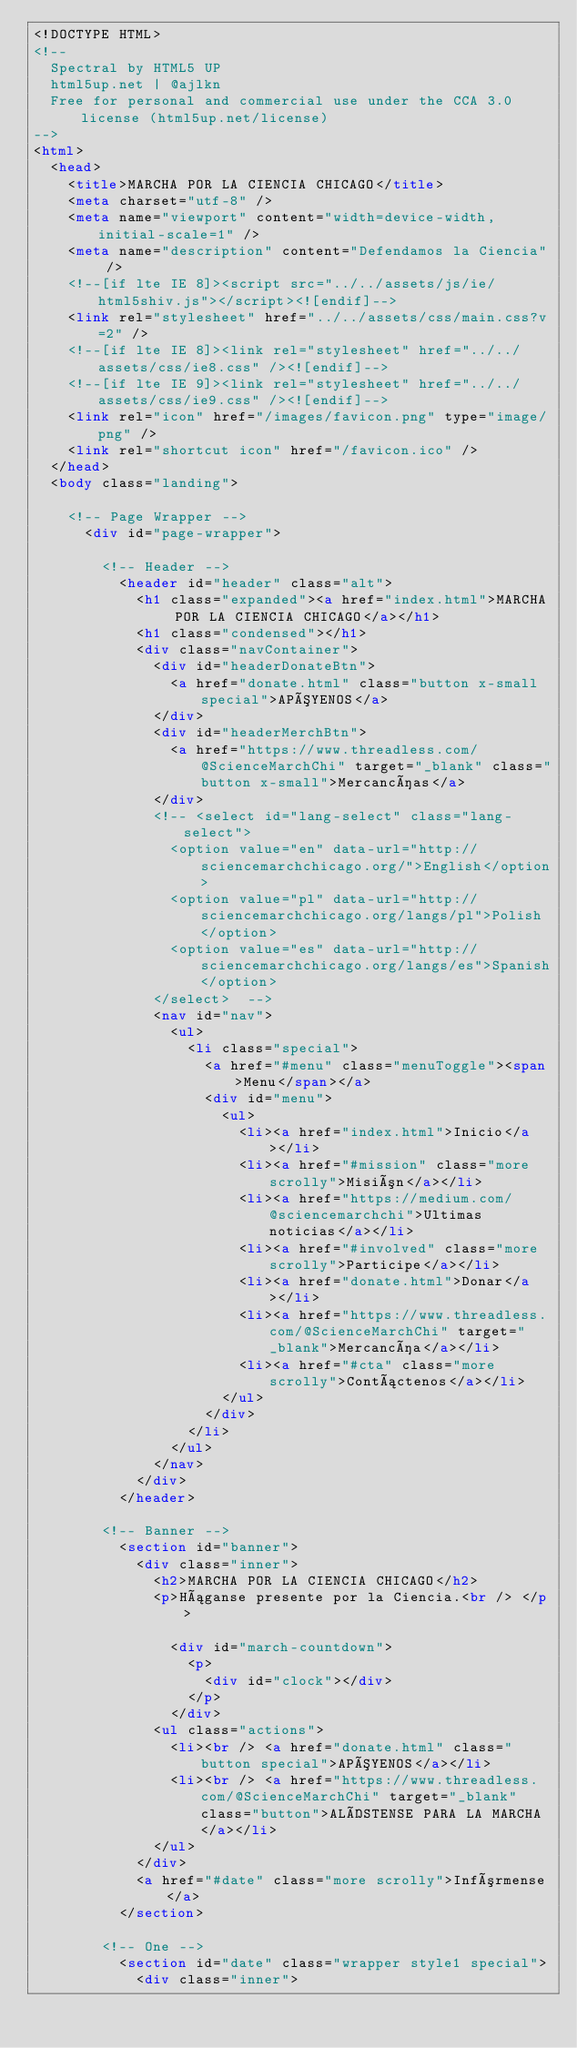<code> <loc_0><loc_0><loc_500><loc_500><_HTML_><!DOCTYPE HTML>
<!--
	Spectral by HTML5 UP
	html5up.net | @ajlkn
	Free for personal and commercial use under the CCA 3.0 license (html5up.net/license)
-->
<html>
	<head>
		<title>MARCHA POR LA CIENCIA CHICAGO</title>
		<meta charset="utf-8" />
		<meta name="viewport" content="width=device-width, initial-scale=1" />
		<meta name="description" content="Defendamos la Ciencia" />
		<!--[if lte IE 8]><script src="../../assets/js/ie/html5shiv.js"></script><![endif]-->
		<link rel="stylesheet" href="../../assets/css/main.css?v=2" />
		<!--[if lte IE 8]><link rel="stylesheet" href="../../assets/css/ie8.css" /><![endif]-->
		<!--[if lte IE 9]><link rel="stylesheet" href="../../assets/css/ie9.css" /><![endif]-->
		<link rel="icon" href="/images/favicon.png" type="image/png" />
		<link rel="shortcut icon" href="/favicon.ico" />
	</head>
	<body class="landing">

		<!-- Page Wrapper -->
			<div id="page-wrapper">

				<!-- Header -->
					<header id="header" class="alt">
						<h1 class="expanded"><a href="index.html">MARCHA POR LA CIENCIA CHICAGO</a></h1>
						<h1 class="condensed"></h1>
						<div class="navContainer">
							<div id="headerDonateBtn">
								<a href="donate.html" class="button x-small special">APÓYENOS</a>
							</div>
							<div id="headerMerchBtn">
								<a href="https://www.threadless.com/@ScienceMarchChi" target="_blank" class="button x-small">Mercancías</a>
							</div>
							<!-- <select id="lang-select" class="lang-select">
								<option value="en" data-url="http://sciencemarchchicago.org/">English</option>
							  <option value="pl" data-url="http://sciencemarchchicago.org/langs/pl">Polish</option>
							  <option value="es" data-url="http://sciencemarchchicago.org/langs/es">Spanish</option>
							</select>  -->
							<nav id="nav">
								<ul>
									<li class="special">
										<a href="#menu" class="menuToggle"><span>Menu</span></a>
										<div id="menu">
											<ul>
												<li><a href="index.html">Inicio</a></li>
												<li><a href="#mission" class="more scrolly">Misión</a></li>
												<li><a href="https://medium.com/@sciencemarchchi">Ultimas noticias</a></li>
												<li><a href="#involved" class="more scrolly">Participe</a></li>
												<li><a href="donate.html">Donar</a></li>
												<li><a href="https://www.threadless.com/@ScienceMarchChi" target="_blank">Mercancía</a></li>
												<li><a href="#cta" class="more scrolly">Contáctenos</a></li>
											</ul>
										</div>
									</li>
								</ul>
							</nav>
						</div>
					</header>

				<!-- Banner -->
					<section id="banner">
						<div class="inner">
							<h2>MARCHA POR LA CIENCIA CHICAGO</h2>
							<p>Háganse presente por la Ciencia.<br /> </p>

								<div id="march-countdown">
									<p>
										<div id="clock"></div>
									</p>
								</div>
							<ul class="actions">
								<li><br /> <a href="donate.html" class="button special">APÓYENOS</a></li>
								<li><br /> <a href="https://www.threadless.com/@ScienceMarchChi" target="_blank" class="button">ALÍSTENSE PARA LA MARCHA</a></li>
							</ul>
						</div>
						<a href="#date" class="more scrolly">Infórmense</a>
					</section>

				<!-- One -->
					<section id="date" class="wrapper style1 special">
						<div class="inner"></code> 